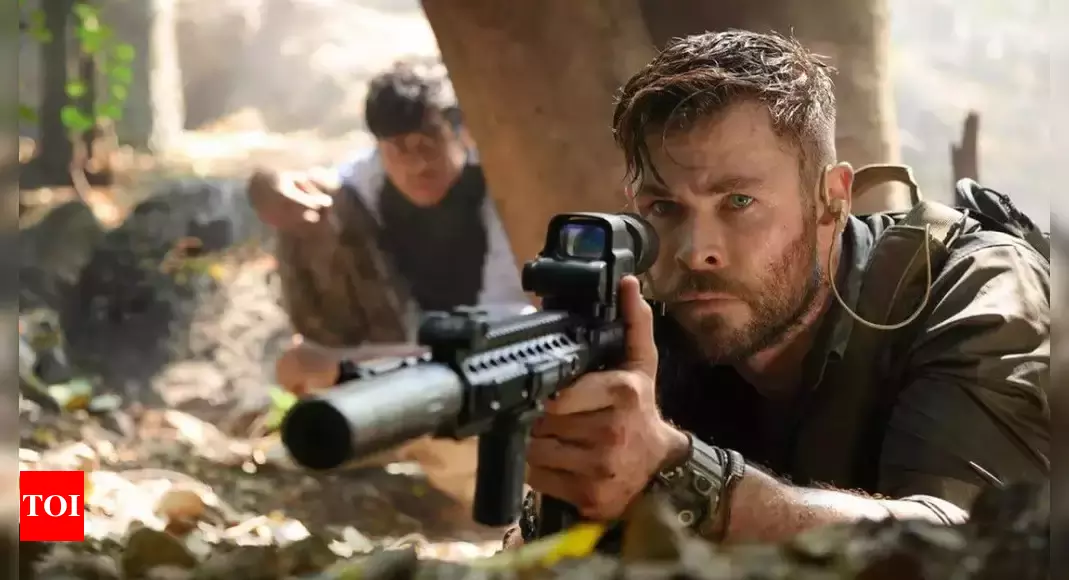Can you describe the emotions conveyed by the actors in the image? The actors in the image convey a range of powerful emotions. The central character, with his intense focus and piercing eyes, exudes determination and readiness. His body language, with a tight grip on his rifle, suggests he is bracing for imminent action or danger. The person in the background, although slightly blurred, mirrors his serious demeanor, indicating they share the sharegpt4v/same urgency and preparedness. The overall mood is one of high tension, caution, and vigilance. What might be the significance of the jungle setting in this scene? The jungle setting plays a crucial role in this scene, enhancing the sense of danger, mystery, and unpredictability. Jungles are often associated with dense foliage, low visibility, and hidden threats, which can add to the characters' challenges. This environment forces the characters to be hyper-aware and ready for any sudden encounters, reflecting the high stakes and intensity of their mission. Additionally, the natural surroundings might symbolize a return to primal survival instincts, highlighting the characters' struggle against both natural and human adversaries. 